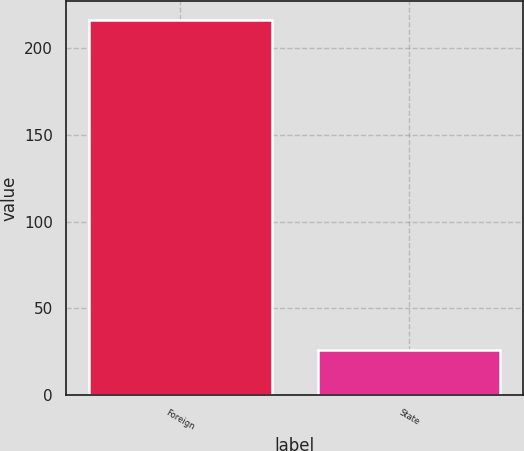Convert chart to OTSL. <chart><loc_0><loc_0><loc_500><loc_500><bar_chart><fcel>Foreign<fcel>State<nl><fcel>216.7<fcel>25.8<nl></chart> 